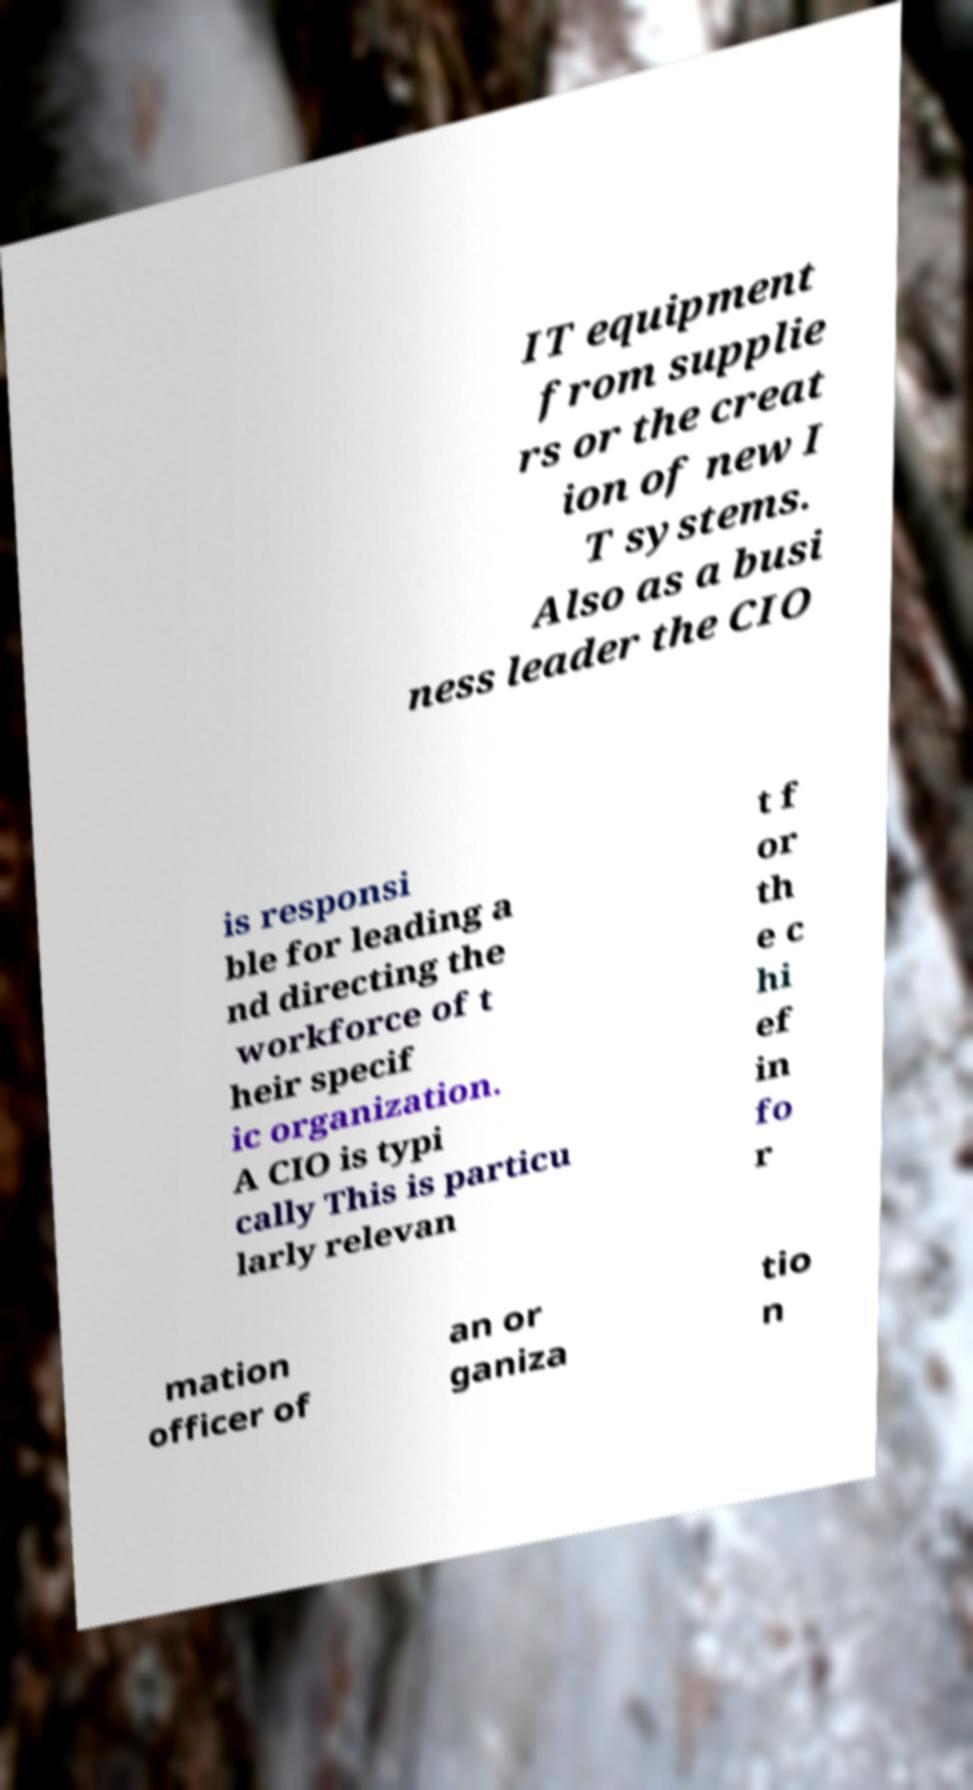Can you read and provide the text displayed in the image?This photo seems to have some interesting text. Can you extract and type it out for me? IT equipment from supplie rs or the creat ion of new I T systems. Also as a busi ness leader the CIO is responsi ble for leading a nd directing the workforce of t heir specif ic organization. A CIO is typi cally This is particu larly relevan t f or th e c hi ef in fo r mation officer of an or ganiza tio n 